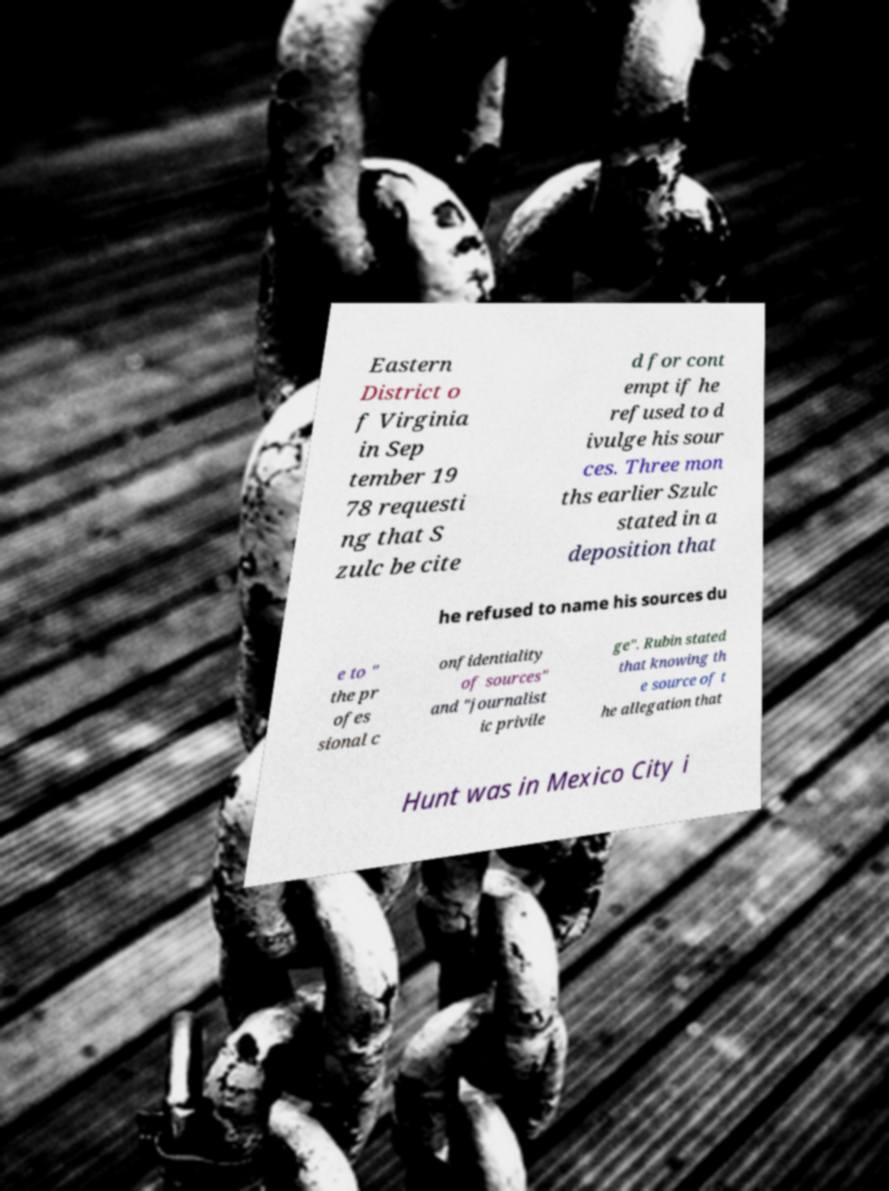There's text embedded in this image that I need extracted. Can you transcribe it verbatim? Eastern District o f Virginia in Sep tember 19 78 requesti ng that S zulc be cite d for cont empt if he refused to d ivulge his sour ces. Three mon ths earlier Szulc stated in a deposition that he refused to name his sources du e to " the pr ofes sional c onfidentiality of sources" and "journalist ic privile ge". Rubin stated that knowing th e source of t he allegation that Hunt was in Mexico City i 